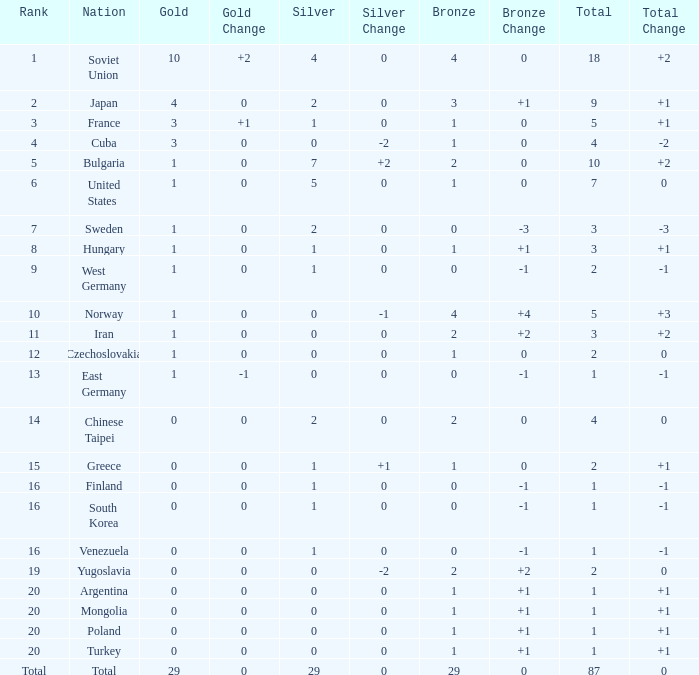Which rank has 1 silver medal and more than 1 gold medal? 3.0. 